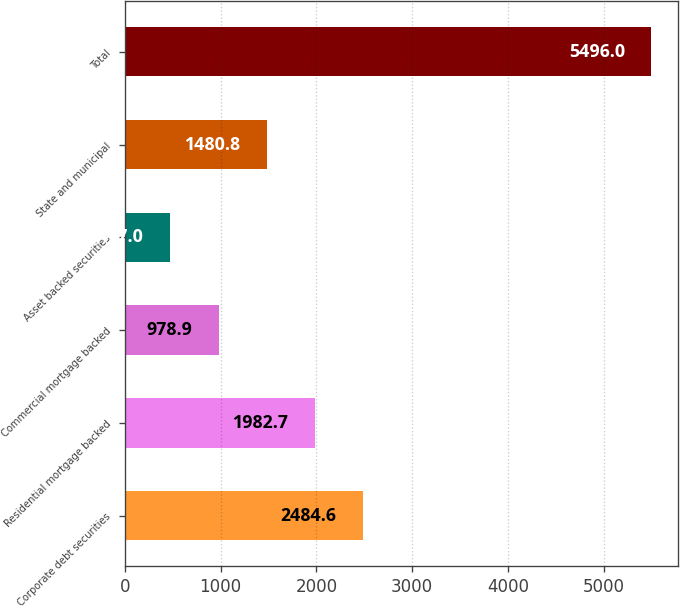<chart> <loc_0><loc_0><loc_500><loc_500><bar_chart><fcel>Corporate debt securities<fcel>Residential mortgage backed<fcel>Commercial mortgage backed<fcel>Asset backed securities<fcel>State and municipal<fcel>Total<nl><fcel>2484.6<fcel>1982.7<fcel>978.9<fcel>477<fcel>1480.8<fcel>5496<nl></chart> 